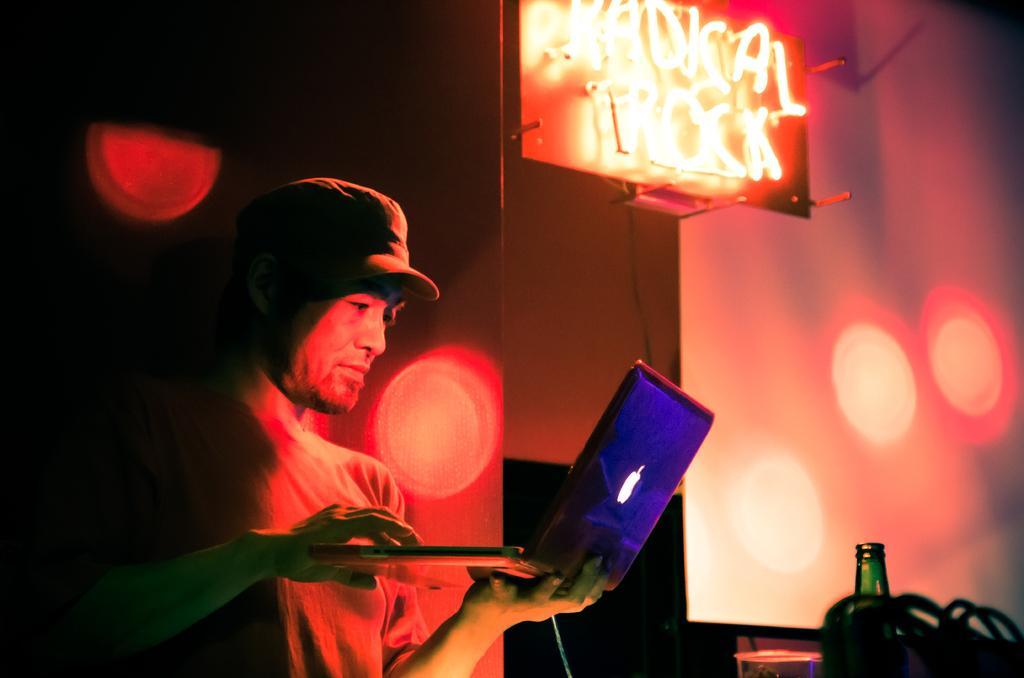How would you summarize this image in a sentence or two? In this picture we can see a man is holding a laptop on the right side of the man there is a bottle, projector screen and a light board. 